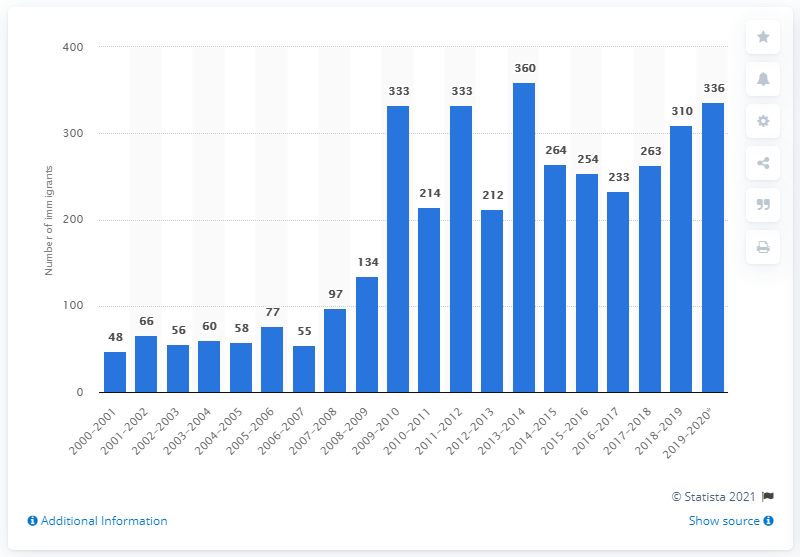Specify some key components in this picture. Between July 1, 2019 and June 30, 2020, a total of 336 new immigrants arrived in Yukon. 